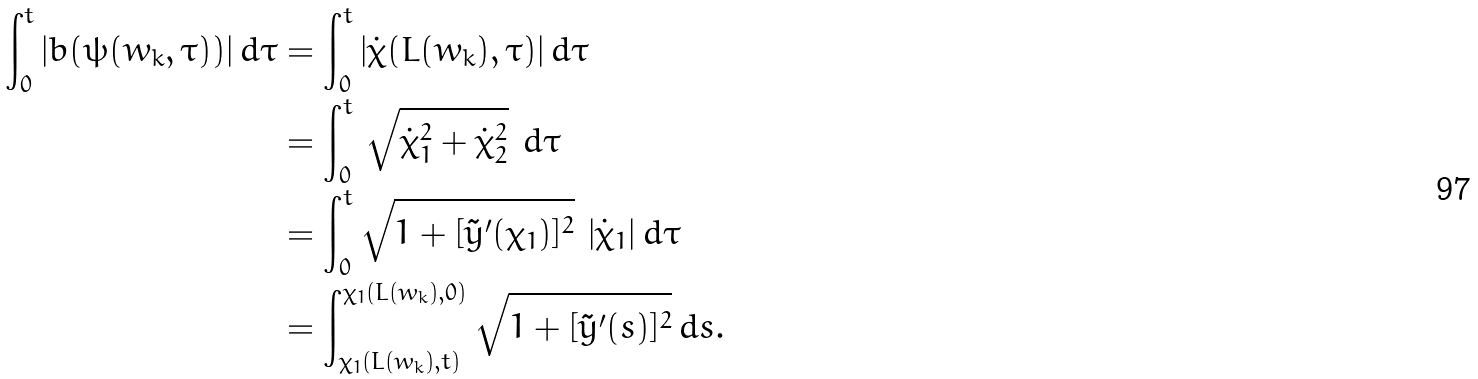Convert formula to latex. <formula><loc_0><loc_0><loc_500><loc_500>\int ^ { t } _ { 0 } | b ( \psi ( w _ { k } , \tau ) ) | \, d \tau & = \int ^ { t } _ { 0 } | \dot { \chi } ( L ( w _ { k } ) , \tau ) | \, d \tau \\ & = \int _ { 0 } ^ { t } \, \sqrt { \dot { \chi } _ { 1 } ^ { 2 } + \dot { \chi } _ { 2 } ^ { 2 } } \ d \tau \\ & = \int _ { 0 } ^ { t } \sqrt { 1 + [ \tilde { y } ^ { \prime } ( \chi _ { 1 } ) ] ^ { 2 } } \ | \dot { \chi } _ { 1 } | \, d \tau \\ & = \int _ { \chi _ { 1 } ( L ( w _ { k } ) , t ) } ^ { \chi _ { 1 } ( L ( w _ { k } ) , 0 ) } \sqrt { 1 + [ \tilde { y } ^ { \prime } ( s ) ] ^ { 2 } } \, d s .</formula> 